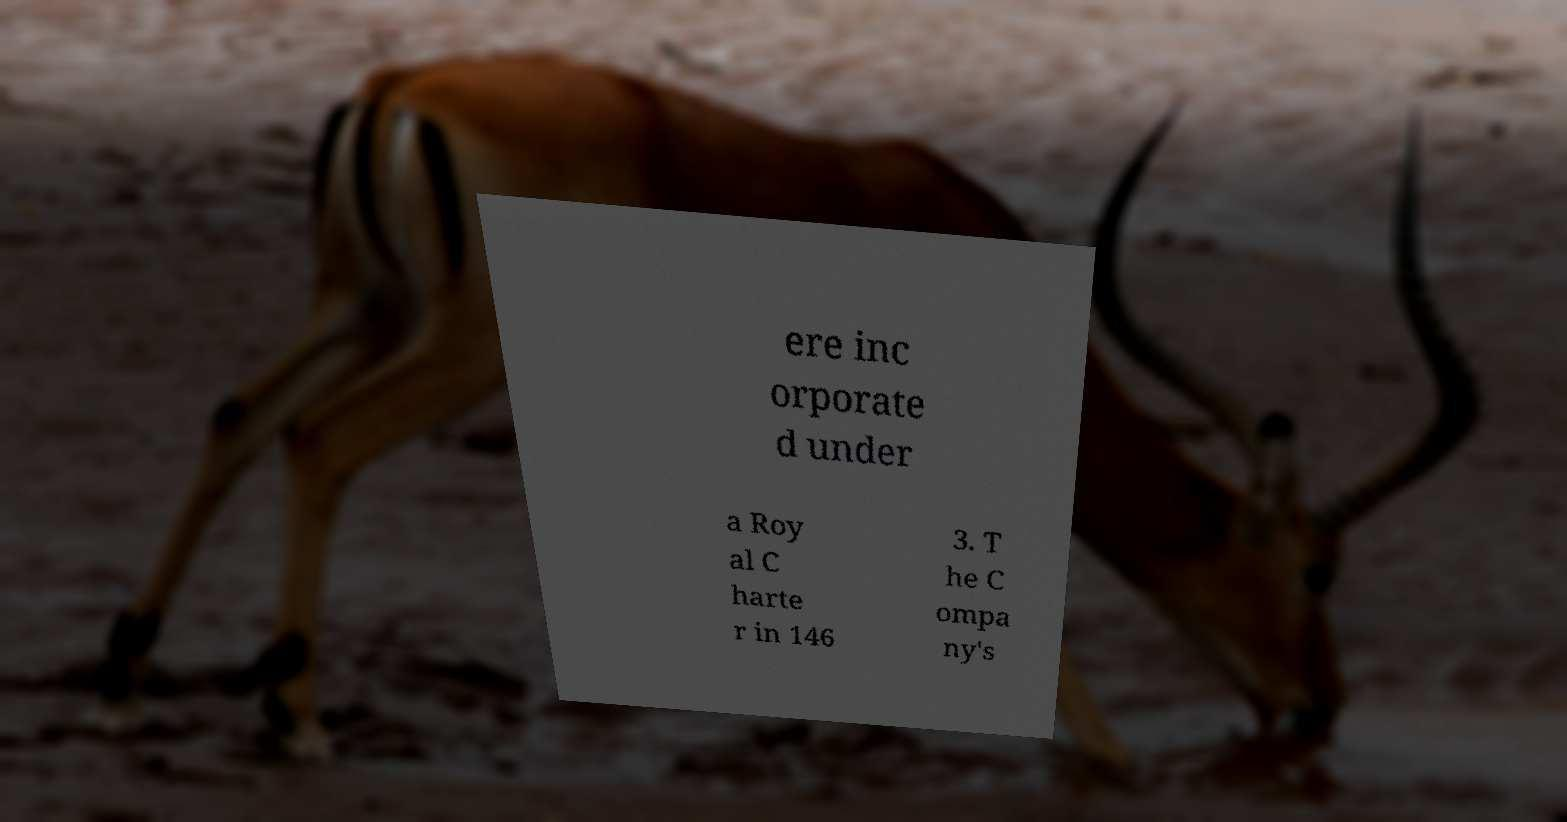For documentation purposes, I need the text within this image transcribed. Could you provide that? ere inc orporate d under a Roy al C harte r in 146 3. T he C ompa ny's 